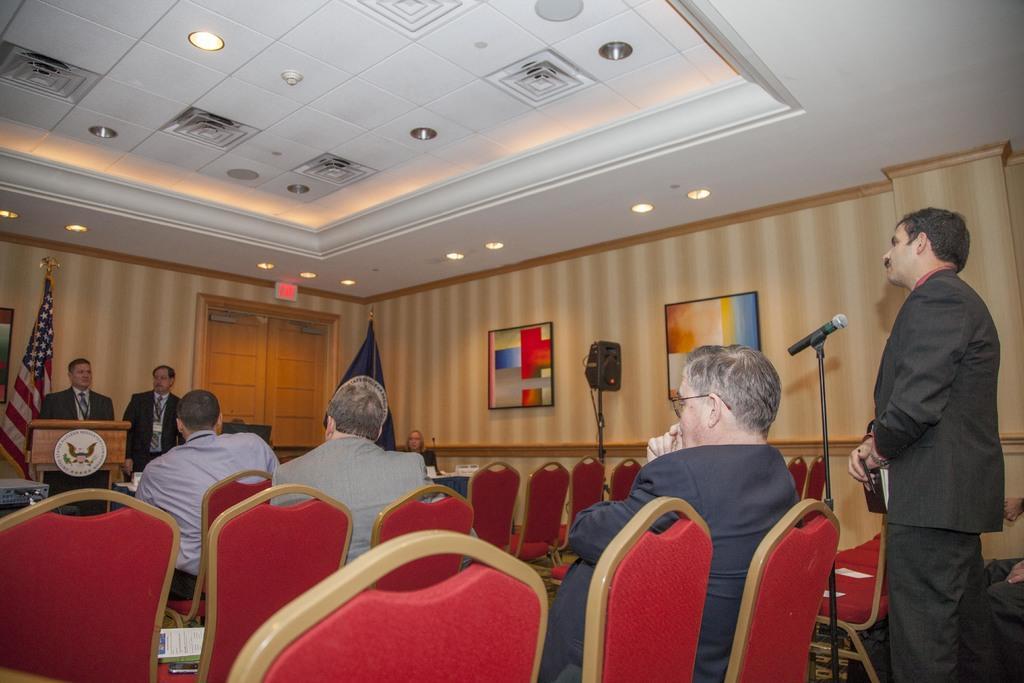How would you summarize this image in a sentence or two? On the right a man is standing and in the middle two people are sitting in the chairs there are lights on the roof on the left a man is standing near the podium. 